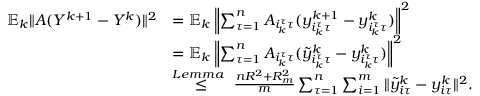Convert formula to latex. <formula><loc_0><loc_0><loc_500><loc_500>\begin{array} { r l } { \mathbb { E } _ { k } \| A ( Y ^ { k + 1 } - Y ^ { k } ) \| ^ { 2 } } & { = \mathbb { E } _ { k } \left \| \sum _ { \tau = 1 } ^ { n } A _ { i _ { k } ^ { \tau } \tau } ( y _ { i _ { k } ^ { \tau } \tau } ^ { k + 1 } - y _ { i _ { k } ^ { \tau } \tau } ^ { k } ) \right \| ^ { 2 } } \\ & { = \mathbb { E } _ { k } \left \| \sum _ { \tau = 1 } ^ { n } A _ { i _ { k } ^ { \tau } \tau } ( { \tilde { y } } _ { i _ { k } ^ { \tau } \tau } ^ { k } - y _ { i _ { k } ^ { \tau } \tau } ^ { k } ) \right \| ^ { 2 } } \\ & { \overset { L e m m a } { \leq } \frac { n R ^ { 2 } + R _ { m } ^ { 2 } } { m } \sum _ { \tau = 1 } ^ { n } \sum _ { i = 1 } ^ { m } \| { \tilde { y } } _ { i \tau } ^ { k } - y _ { i \tau } ^ { k } \| ^ { 2 } . } \end{array}</formula> 